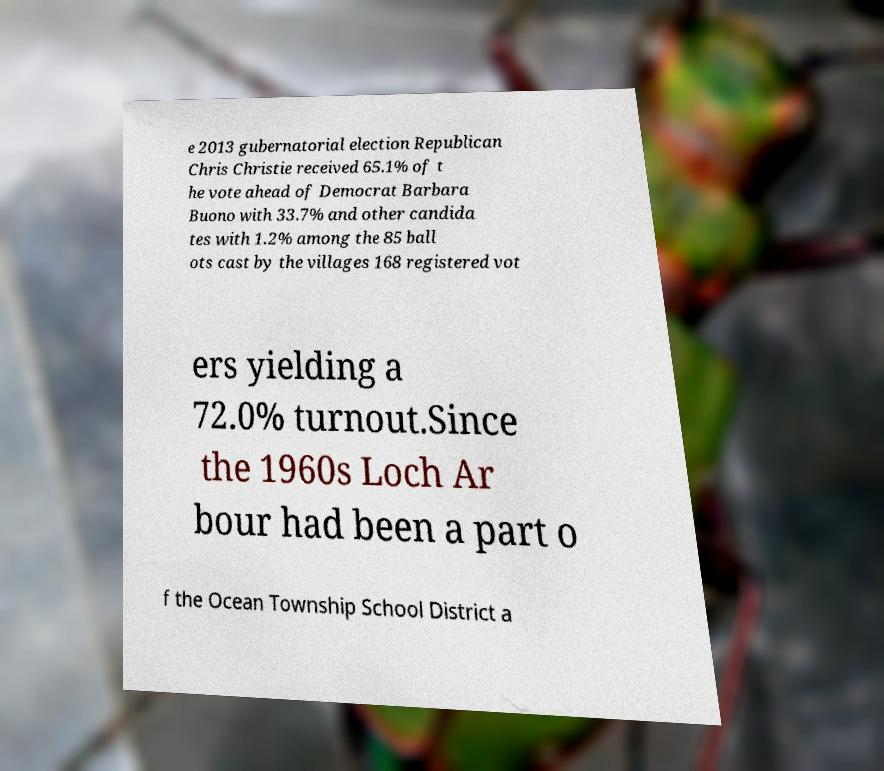Can you read and provide the text displayed in the image?This photo seems to have some interesting text. Can you extract and type it out for me? e 2013 gubernatorial election Republican Chris Christie received 65.1% of t he vote ahead of Democrat Barbara Buono with 33.7% and other candida tes with 1.2% among the 85 ball ots cast by the villages 168 registered vot ers yielding a 72.0% turnout.Since the 1960s Loch Ar bour had been a part o f the Ocean Township School District a 